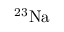<formula> <loc_0><loc_0><loc_500><loc_500>^ { 2 3 } N a</formula> 